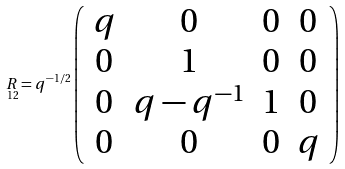Convert formula to latex. <formula><loc_0><loc_0><loc_500><loc_500>\underset { 1 2 } { R } = q ^ { - 1 / 2 } \left ( \begin{array} { c c c c } q & 0 & 0 & 0 \\ 0 & 1 & 0 & 0 \\ 0 & q - q ^ { - 1 } & 1 & 0 \\ 0 & 0 & 0 & q \end{array} \right )</formula> 